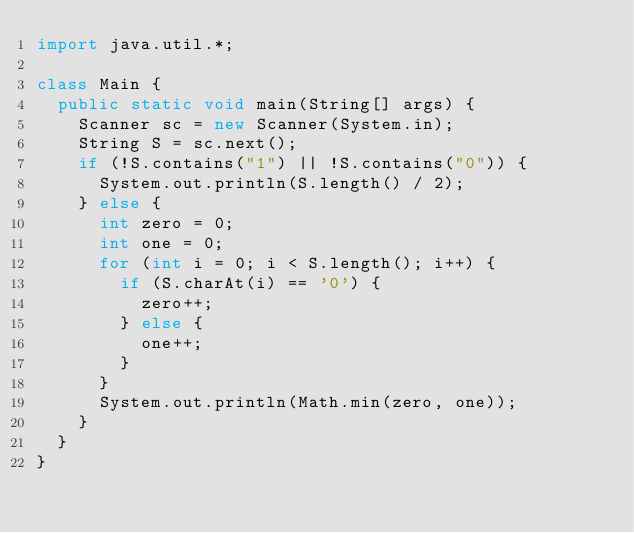Convert code to text. <code><loc_0><loc_0><loc_500><loc_500><_Java_>import java.util.*;

class Main {
  public static void main(String[] args) {
    Scanner sc = new Scanner(System.in);
    String S = sc.next();
    if (!S.contains("1") || !S.contains("0")) {
      System.out.println(S.length() / 2);
    } else {
      int zero = 0;
      int one = 0;
      for (int i = 0; i < S.length(); i++) {
        if (S.charAt(i) == '0') {
          zero++;
        } else {
          one++;
        }
      }
      System.out.println(Math.min(zero, one));
    }
  }
}</code> 